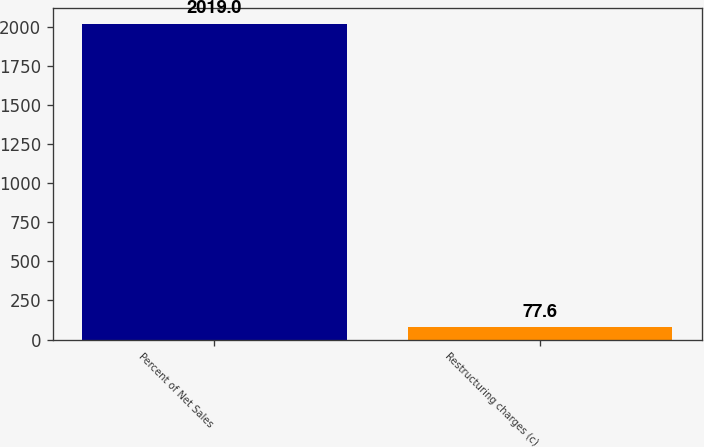Convert chart to OTSL. <chart><loc_0><loc_0><loc_500><loc_500><bar_chart><fcel>Percent of Net Sales<fcel>Restructuring charges (c)<nl><fcel>2019<fcel>77.6<nl></chart> 